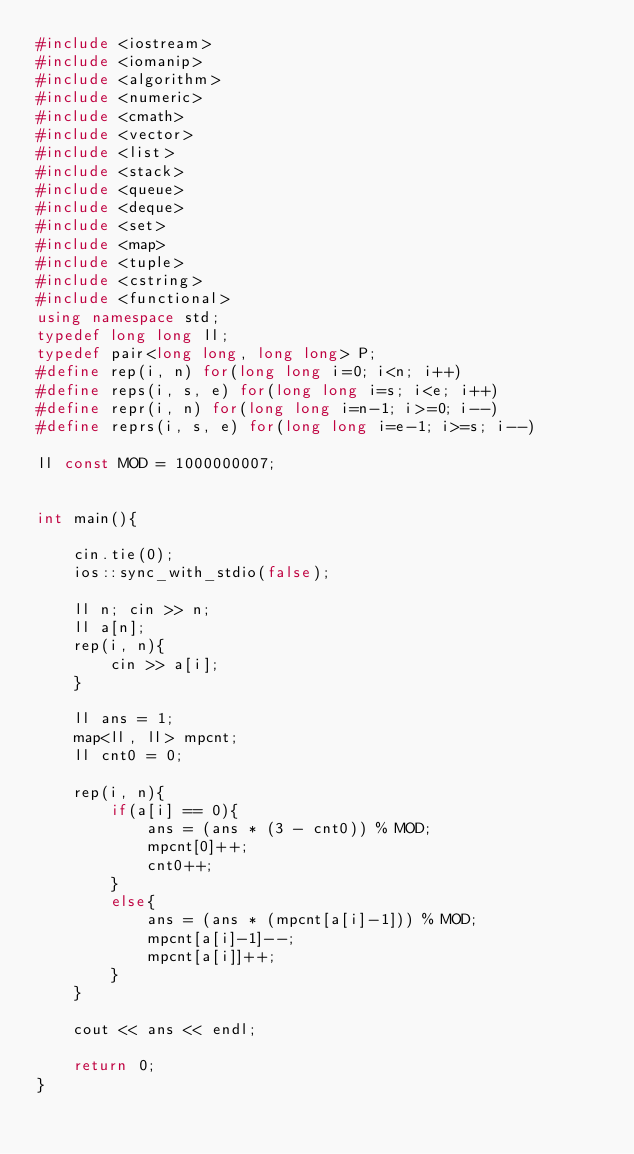Convert code to text. <code><loc_0><loc_0><loc_500><loc_500><_C++_>#include <iostream>
#include <iomanip>
#include <algorithm>
#include <numeric>
#include <cmath>
#include <vector>
#include <list>
#include <stack>
#include <queue>
#include <deque>
#include <set>
#include <map>
#include <tuple>
#include <cstring>
#include <functional>
using namespace std;
typedef long long ll;
typedef pair<long long, long long> P;
#define rep(i, n) for(long long i=0; i<n; i++)
#define reps(i, s, e) for(long long i=s; i<e; i++)
#define repr(i, n) for(long long i=n-1; i>=0; i--)
#define reprs(i, s, e) for(long long i=e-1; i>=s; i--)

ll const MOD = 1000000007;


int main(){

    cin.tie(0);
    ios::sync_with_stdio(false);

    ll n; cin >> n;
    ll a[n];
    rep(i, n){
        cin >> a[i];
    }

    ll ans = 1;
    map<ll, ll> mpcnt;
    ll cnt0 = 0;

    rep(i, n){
        if(a[i] == 0){
            ans = (ans * (3 - cnt0)) % MOD;
            mpcnt[0]++;
            cnt0++;
        }
        else{
            ans = (ans * (mpcnt[a[i]-1])) % MOD;
            mpcnt[a[i]-1]--;
            mpcnt[a[i]]++;
        }
    }

    cout << ans << endl;

    return 0;
}</code> 